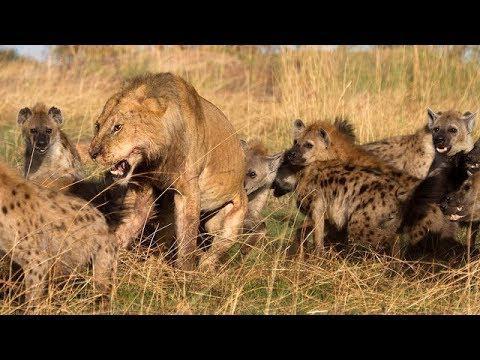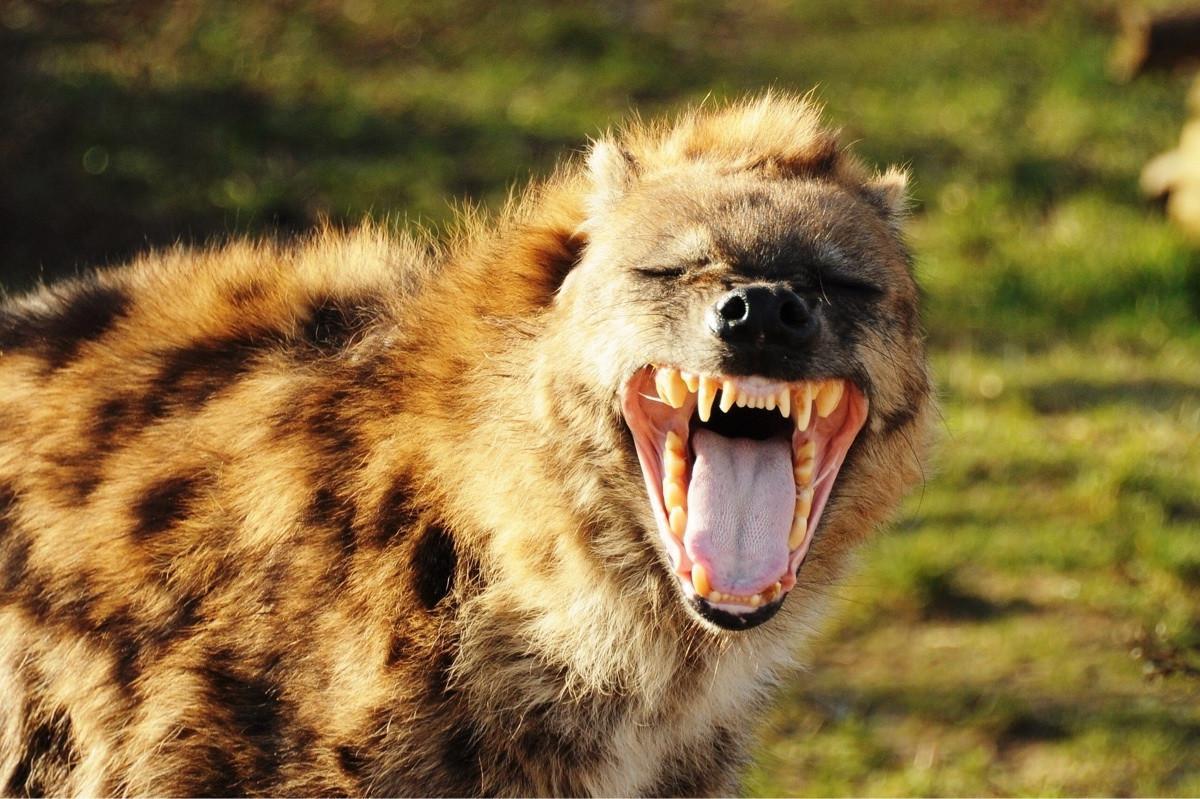The first image is the image on the left, the second image is the image on the right. Analyze the images presented: Is the assertion "The lefthand image includes a lion, and the righthand image contains only a fang-baring hyena." valid? Answer yes or no. Yes. The first image is the image on the left, the second image is the image on the right. Evaluate the accuracy of this statement regarding the images: "The right image contains at least two animals.". Is it true? Answer yes or no. No. 